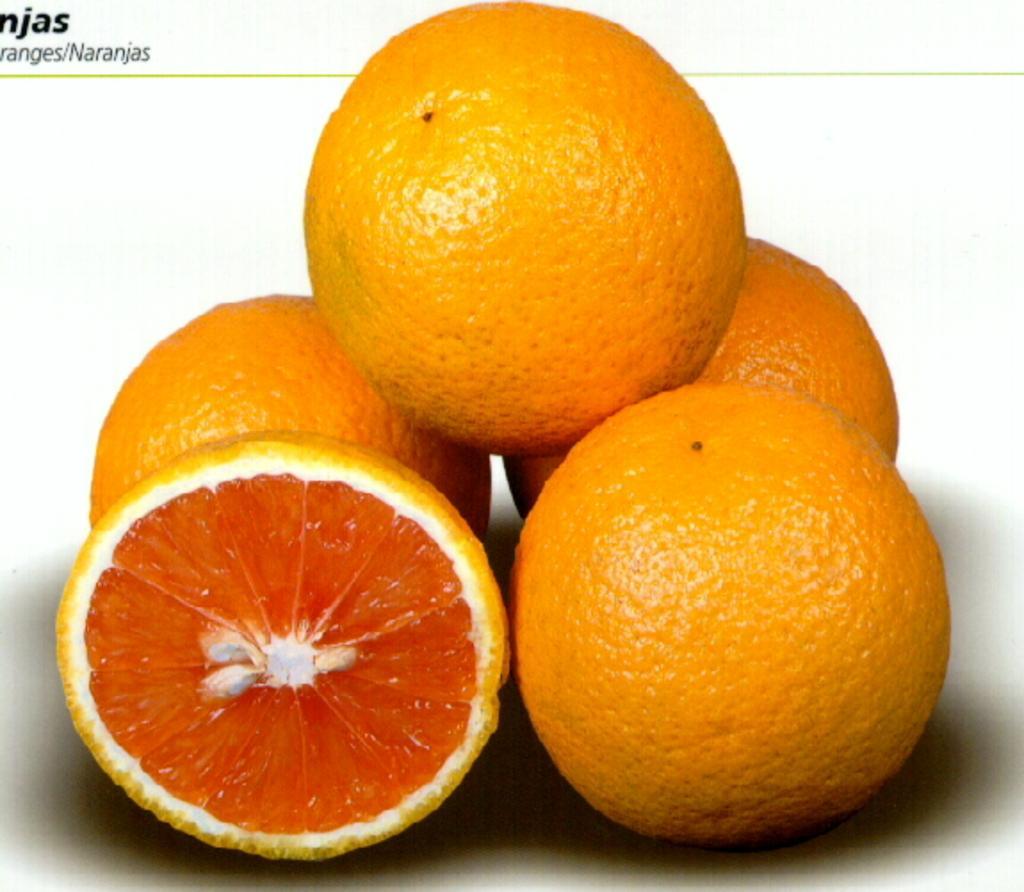Describe this image in one or two sentences. In this image there are some lemons kept on the floor as we can see in middle of this image, and there is half cutted lemon on the bottom left side of this image. There is some text written on the top left side of this image. 